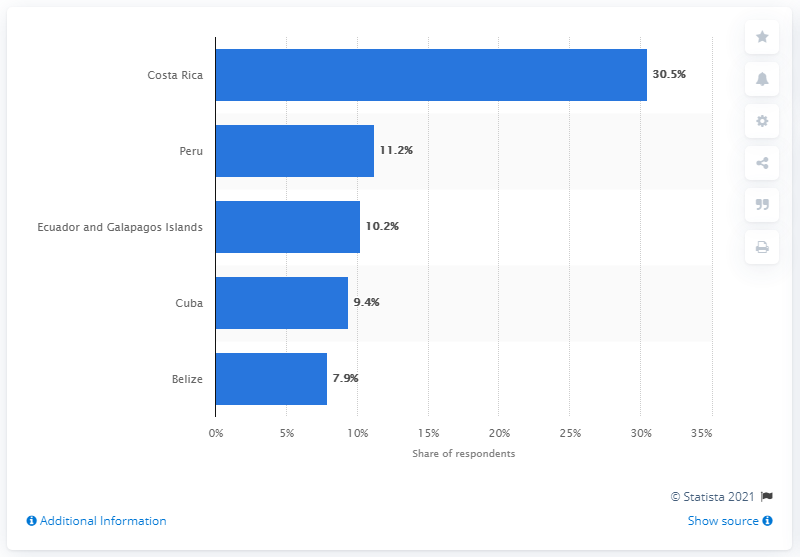Highlight a few significant elements in this photo. In 2015, Costa Rica was considered the most promising and rapidly developing travel destination in Central and South America. 